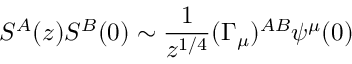<formula> <loc_0><loc_0><loc_500><loc_500>S ^ { A } ( z ) S ^ { B } ( 0 ) \sim \frac { 1 } { z ^ { 1 / 4 } } ( \Gamma _ { \mu } ) ^ { A B } \psi ^ { \mu } ( 0 )</formula> 